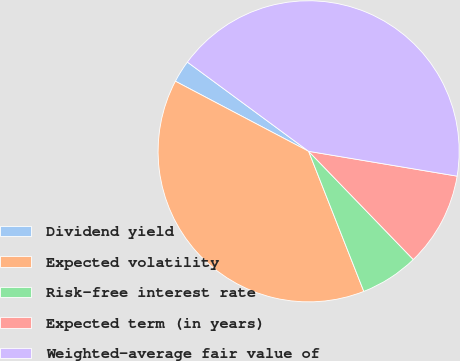Convert chart. <chart><loc_0><loc_0><loc_500><loc_500><pie_chart><fcel>Dividend yield<fcel>Expected volatility<fcel>Risk-free interest rate<fcel>Expected term (in years)<fcel>Weighted-average fair value of<nl><fcel>2.39%<fcel>38.68%<fcel>6.26%<fcel>10.13%<fcel>42.54%<nl></chart> 